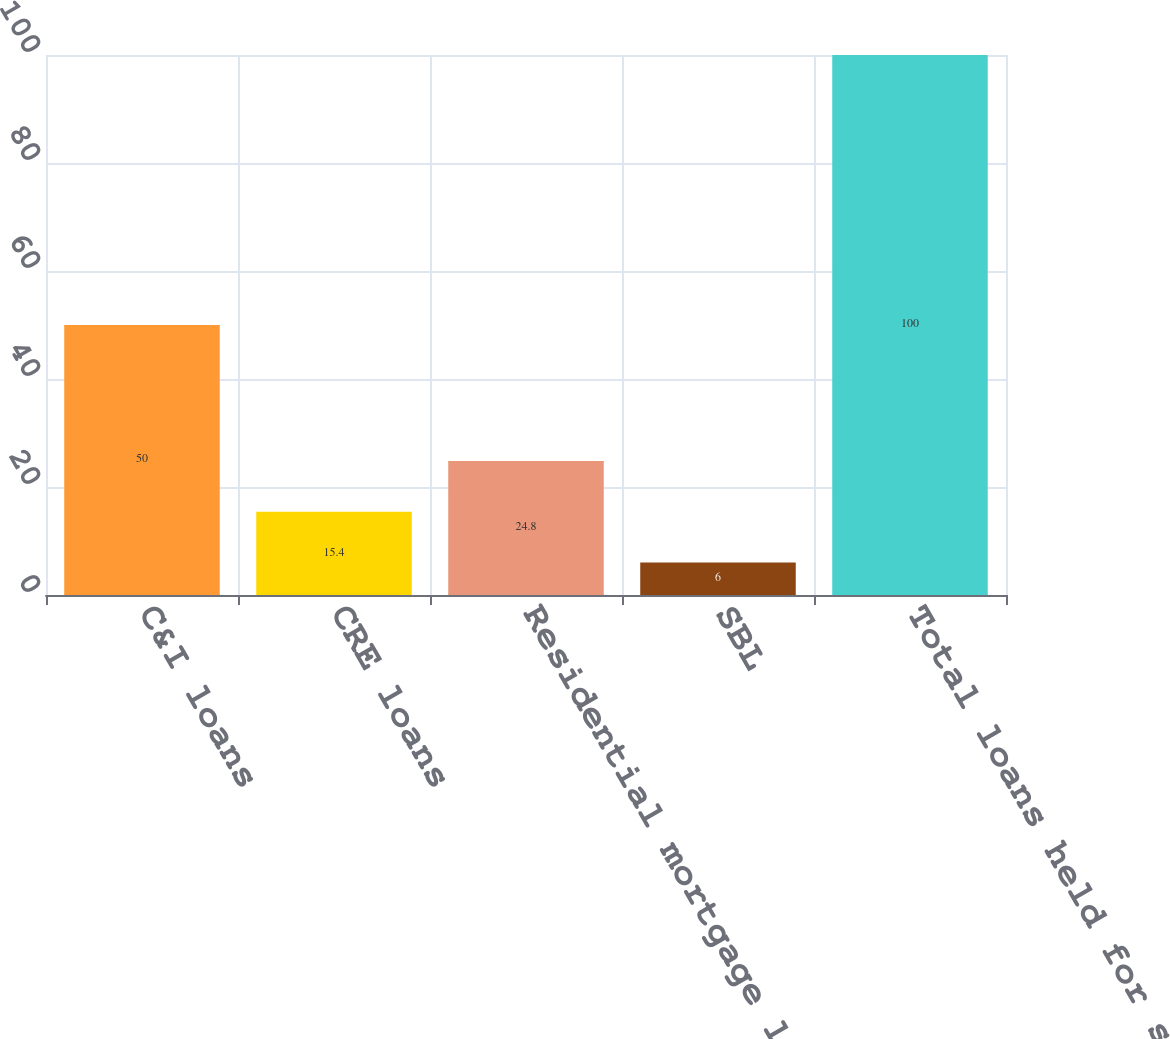Convert chart. <chart><loc_0><loc_0><loc_500><loc_500><bar_chart><fcel>C&I loans<fcel>CRE loans<fcel>Residential mortgage loans<fcel>SBL<fcel>Total loans held for sale and<nl><fcel>50<fcel>15.4<fcel>24.8<fcel>6<fcel>100<nl></chart> 